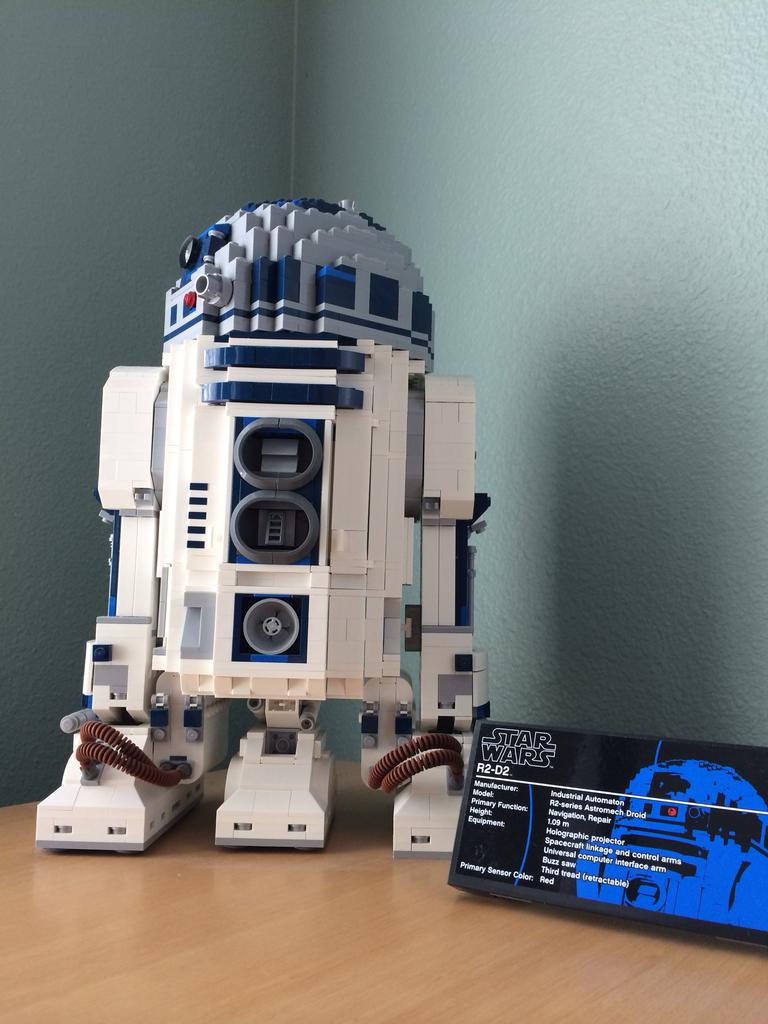What is the main subject in the image? There is a machine in the image. What else can be seen in the image besides the machine? There are objects on a wooden surface in the image. What is visible in the background of the image? There is a wall visible in the background of the image. What type of education can be seen in the caption of the image? There is no caption present in the image, so it is not possible to determine what type of education might be mentioned. 